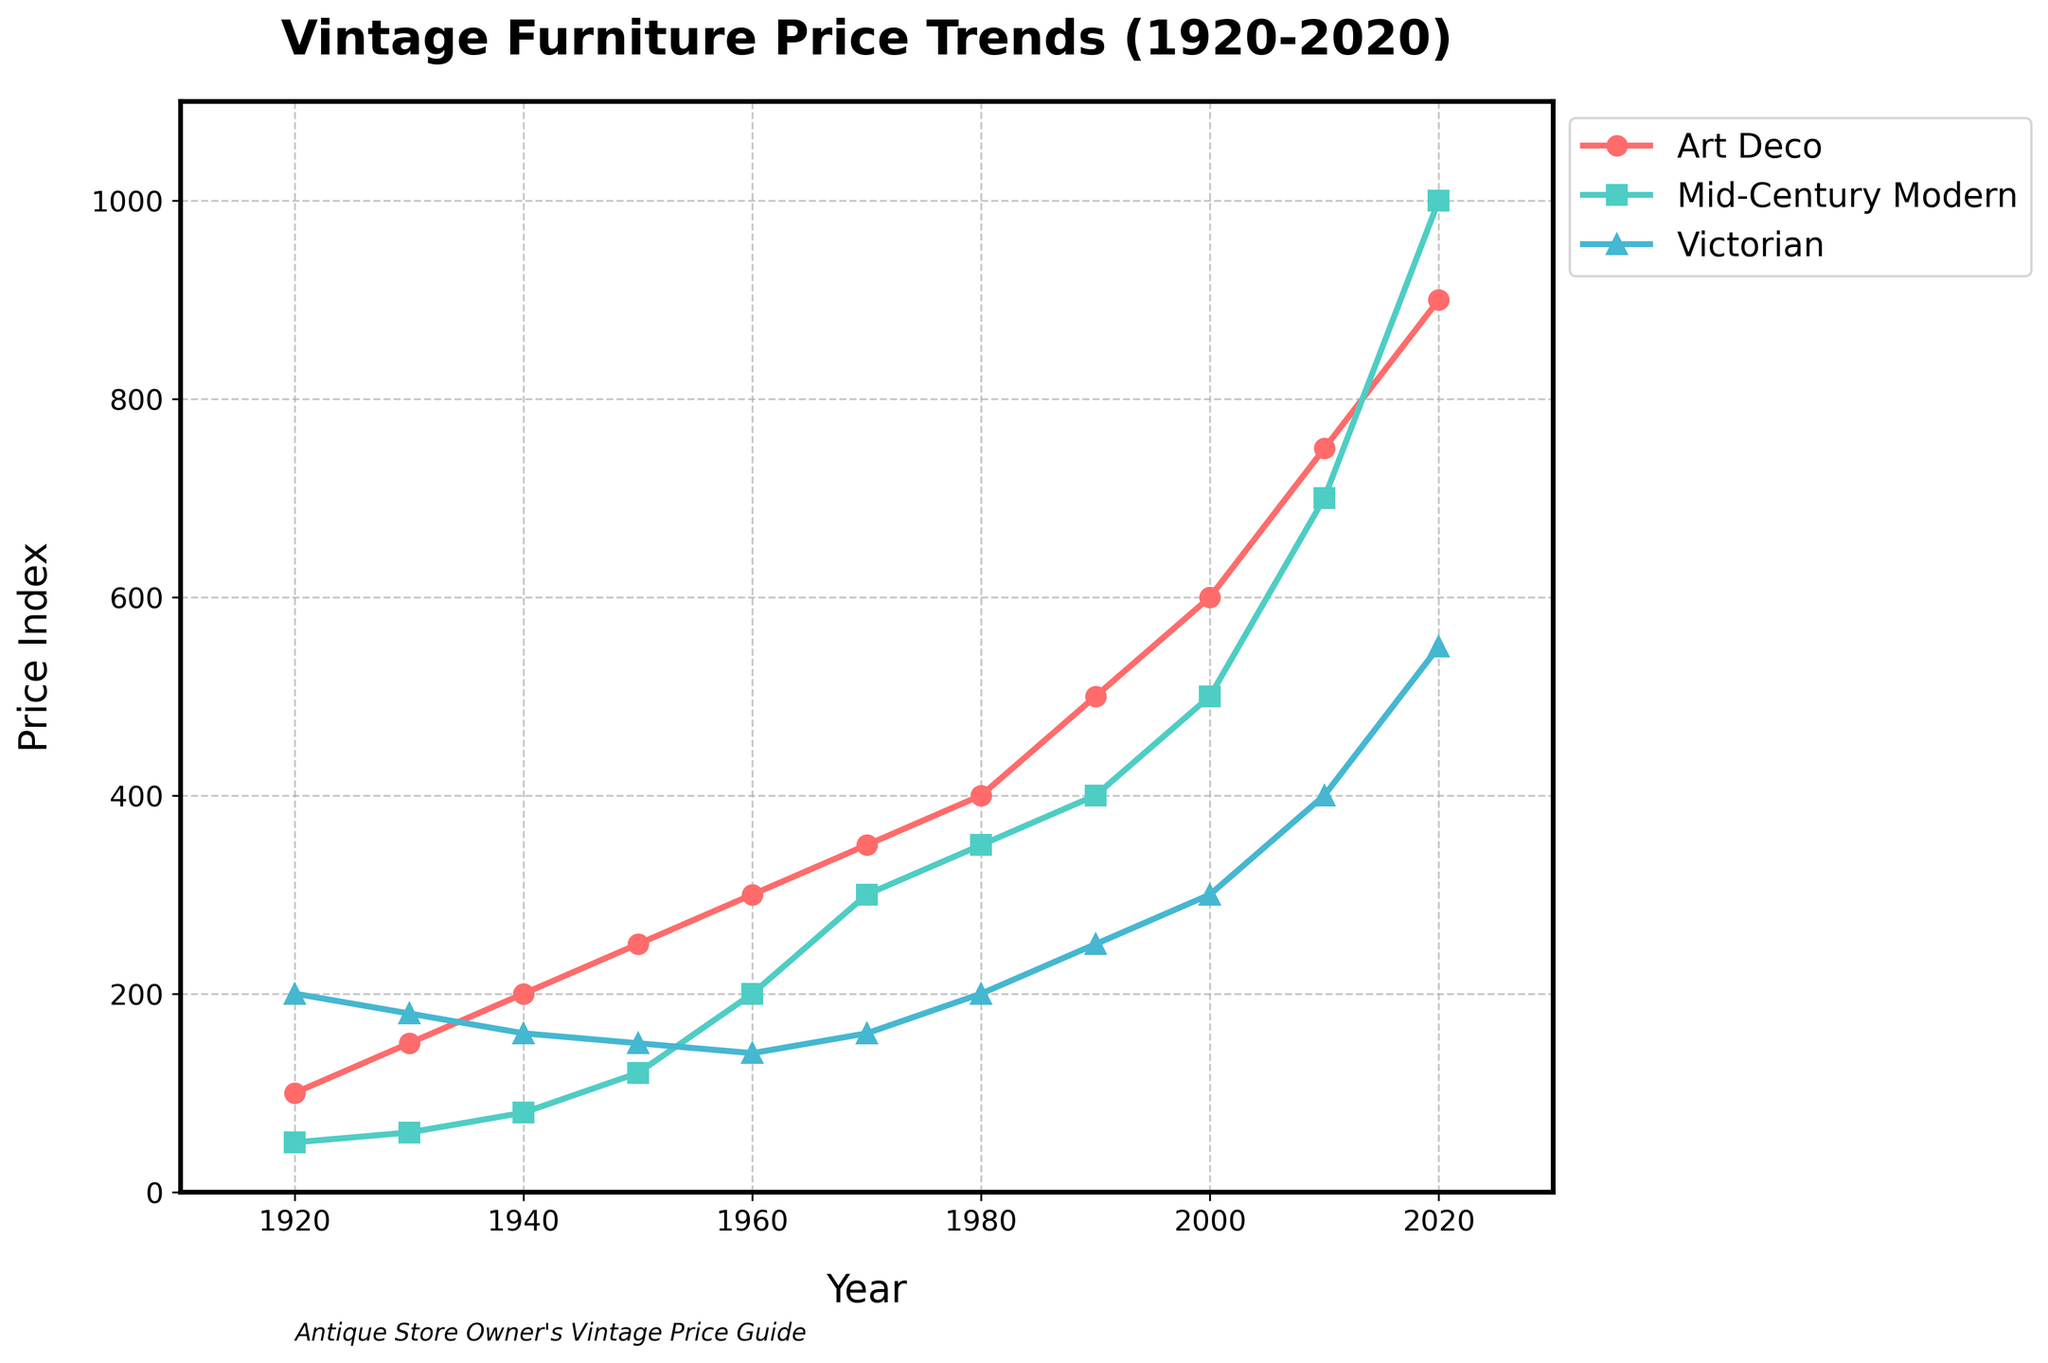What's the highest price for Art Deco and in which year did it occur? Art Deco's highest price is at the top of its line, which is 900 in the year 2020.
Answer: 900, 2020 Which vintage furniture style had the highest price in 1980? By comparing the prices in 1980, we see Art Deco is 400, Mid-Century Modern is 350, and Victorian is 200. Art Deco has the highest price.
Answer: Art Deco What's the average price of Victorian furniture over the century? Sum of Victorian prices (200 + 180 + 160 + 150 + 140 + 160 + 200 + 250 + 300 + 400 + 550) = 2690. Number of data points = 11. Average price = 2690 / 11 = ~244.5.
Answer: 244.5 In what period did Mid-Century Modern furniture see the steepest rise in price? Check the period with the steepest slope on the Mid-Century Modern line. The steepest rise occurs between 2010 and 2020, where the price jumps from 700 to 1000.
Answer: 2010-2020 Which style had the least price increase from 1920 to 2020? Calculate the differences: Art Deco (900-100=800), Mid-Century Modern (1000-50=950), Victorian (550-200=350). Victorian has the smallest increase.
Answer: Victorian When comparing 1960 prices, which style outperformed the others? In 1960, prices are Art Deco: 300, Mid-Century Modern: 200, Victorian: 140. Art Deco has the highest price.
Answer: Art Deco How did the price of Art Deco furniture change between 1940 and 1960? 1940 price is 200, and 1960 price is 300. The change = 300 - 200 = 100.
Answer: Increased by 100 Which style had a higher price in 1950, Victorian or Mid-Century Modern? In 1950, Victorian price is 150, whereas Mid-Century Modern price is 120. Victorian is higher.
Answer: Victorian What's the total sum of the prices for Mid-Century Modern from 1920 to 1970? Sum of Mid-Century Modern prices: 50 + 60 + 80 + 120 + 200 + 300 = 810.
Answer: 810 In the year 2000, what is the ratio of the price of Art Deco to that of Victorian? In 2000, Art Deco price is 600 and Victorian price is 300. Ratio = 600/300 = 2:1.
Answer: 2:1 